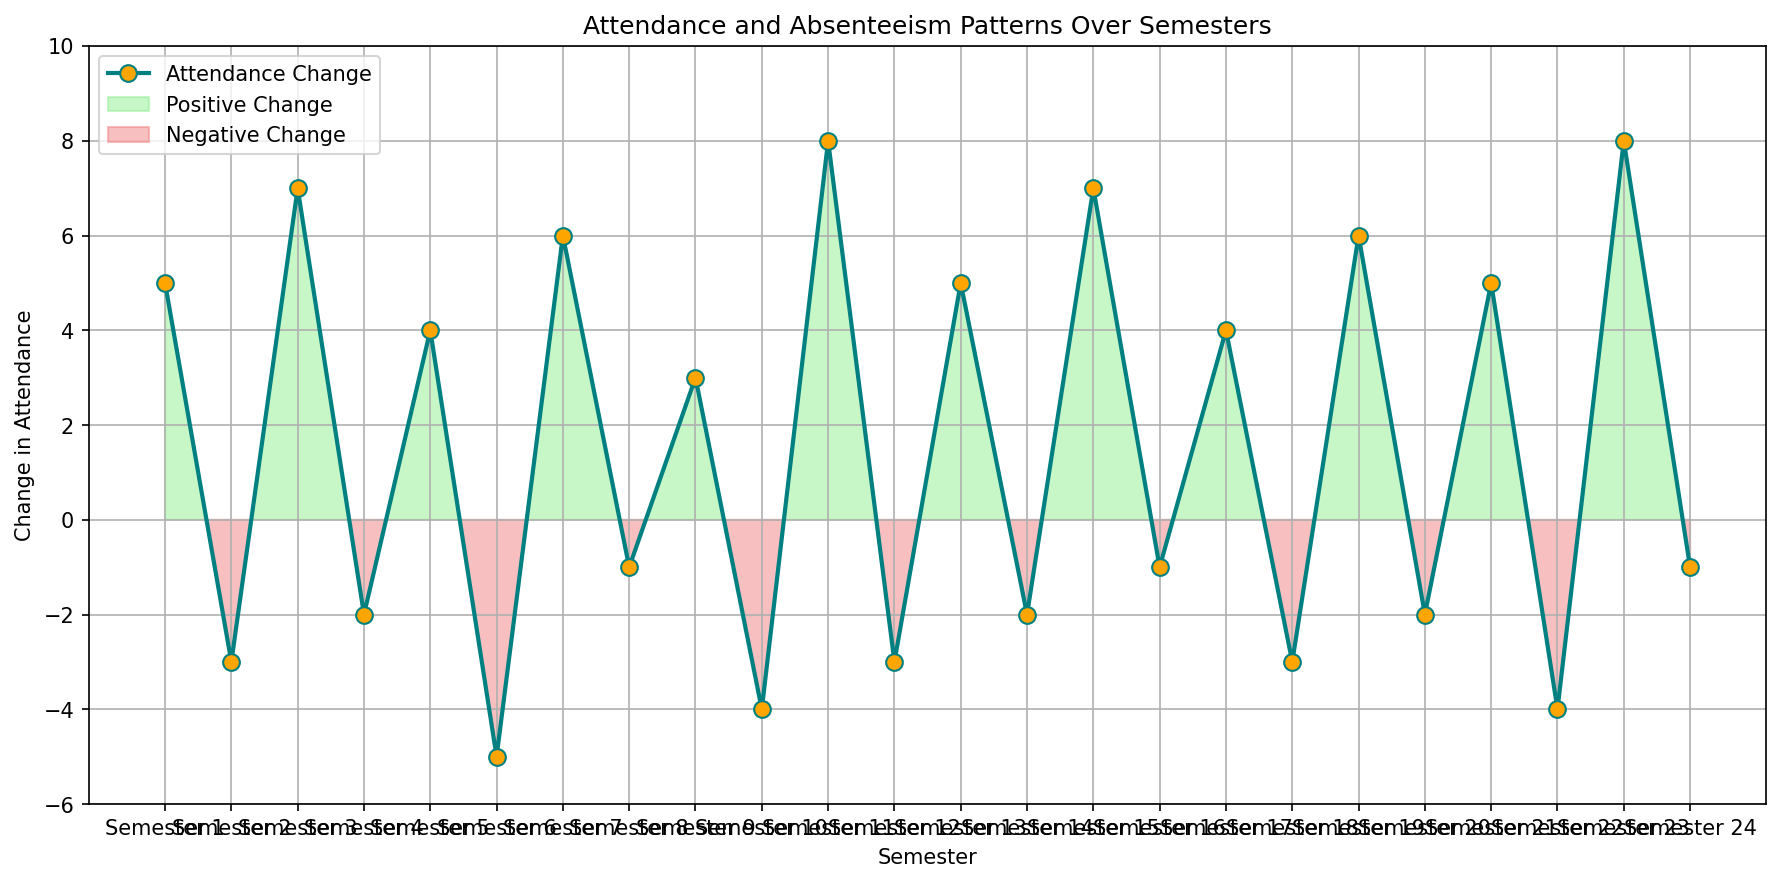What is the highest positive attendance change and in which semester does it occur? By observing the plot, identify the point with the maximum upward value on the y-axis and its corresponding x-axis value. The highest positive change is around 8, which occurs in Semester 11 and Semester 23.
Answer: 8 in Semesters 11 and 23 What is the cumulative sum of attendance changes over the first 4 semesters? Look at the y-values for the first 4 data points: 5, -3, 7, -2. Sum these values: 5 + (-3) + 7 + (-2) = 7
Answer: 7 Which semesters show a negative attendance change? Examine the y-axis values for each plotted data point and identify those below zero. Negative changes occur in Semesters 2, 4, 6, 8, 10, 12, 14, 16, 18, 20, and 22.
Answer: Semesters 2, 4, 6, 8, 10, 12, 14, 16, 18, 20, 22 How many semesters have a positive attendance change greater than or equal to 5? Identify y-values for data points where the attendance change is ≥ 5. The points meeting this condition are in Semesters 1, 3, 11, 13, 15, 19, 21, and 23. Count these semesters.
Answer: 8 Compare the attendance change in Semester 7 and Semester 8. Which is higher and by how much? Locate the y-values for both semesters, which are 6 for Semester 7 and -1 for Semester 8. Subtract the smaller from the larger: 6 - (-1) = 7. Semester 7 has a higher change by 7 points.
Answer: Semester 7 by 7 points What is the average attendance change over the entire period? Calculate the sum of all attendance changes and divide by the number of semesters (24). Sum = 5 + (-3) + 7 + (-2) + 4 + (-5) + 6 + (-1) + 3 + (-4) + 8 + (-3) + 5 + (-2) + 7 + (-1) + 4 + (-3) + 6 + (-2) + 5 + (-4) + 8 + (-1) = 44. Average = 44 / 24.
Answer: 1.83 Identify the semesters with the lowest attendance change and provide its value. Observe the graph for the minimum y-value on the plot. The lowest values are -5. Locate the corresponding semesters, which is Semester 6.
Answer: Semester 6, -5 